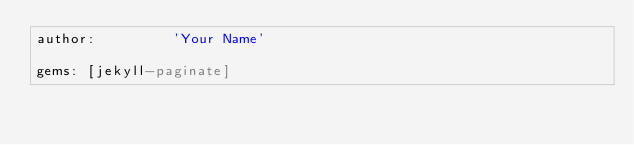<code> <loc_0><loc_0><loc_500><loc_500><_YAML_>author:         'Your Name'

gems: [jekyll-paginate]
</code> 